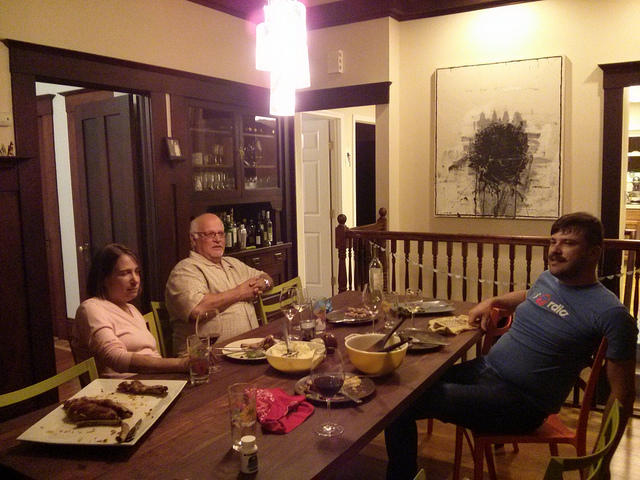Please identify all text content in this image. rolla I 